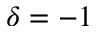<formula> <loc_0><loc_0><loc_500><loc_500>\delta = - 1</formula> 